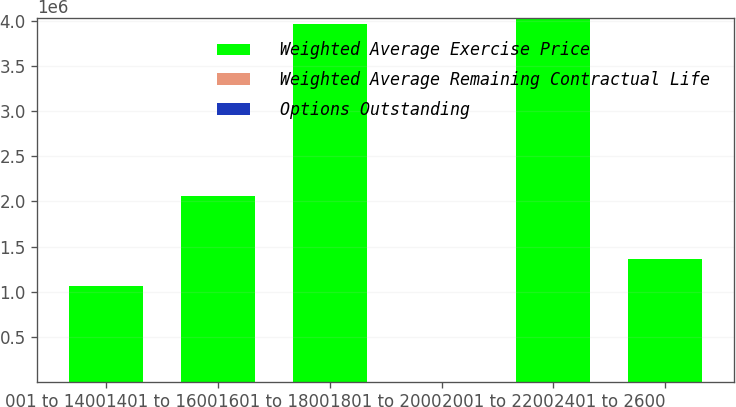Convert chart. <chart><loc_0><loc_0><loc_500><loc_500><stacked_bar_chart><ecel><fcel>001 to 1400<fcel>1401 to 1600<fcel>1601 to 1800<fcel>1801 to 2000<fcel>2001 to 2200<fcel>2401 to 2600<nl><fcel>Weighted Average Exercise Price<fcel>1.05924e+06<fcel>2.05776e+06<fcel>3.97181e+06<fcel>17.55<fcel>4.03304e+06<fcel>1.36403e+06<nl><fcel>Weighted Average Remaining Contractual Life<fcel>5.2<fcel>5.97<fcel>6.28<fcel>8.34<fcel>4.12<fcel>3.3<nl><fcel>Options Outstanding<fcel>13.57<fcel>15.91<fcel>17.55<fcel>18.64<fcel>20.62<fcel>24.39<nl></chart> 